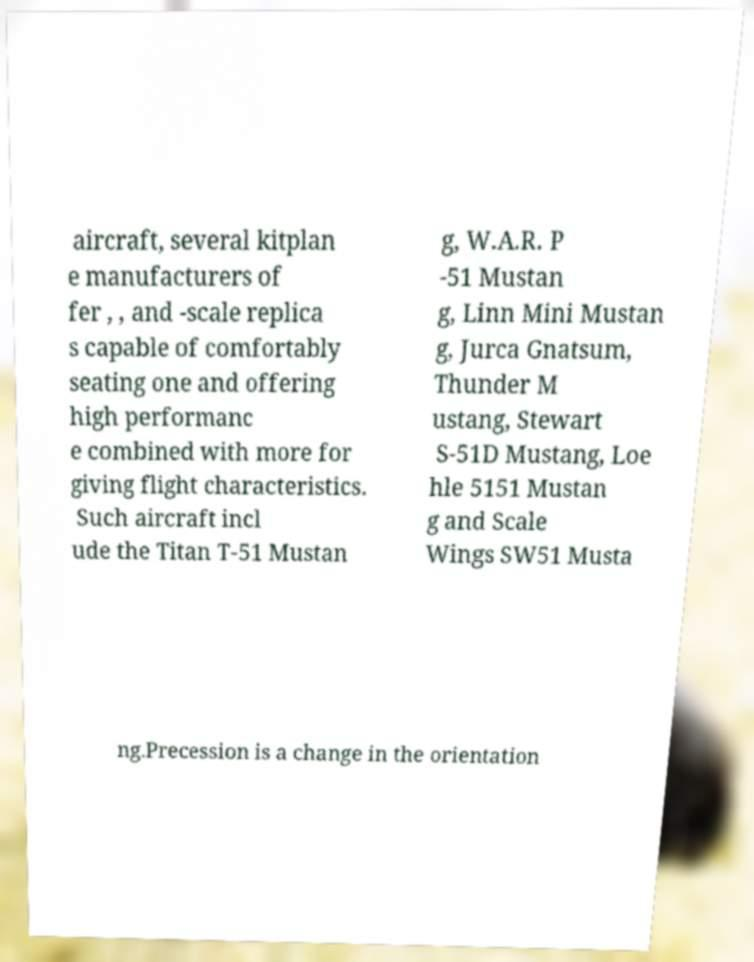Could you assist in decoding the text presented in this image and type it out clearly? aircraft, several kitplan e manufacturers of fer , , and -scale replica s capable of comfortably seating one and offering high performanc e combined with more for giving flight characteristics. Such aircraft incl ude the Titan T-51 Mustan g, W.A.R. P -51 Mustan g, Linn Mini Mustan g, Jurca Gnatsum, Thunder M ustang, Stewart S-51D Mustang, Loe hle 5151 Mustan g and Scale Wings SW51 Musta ng.Precession is a change in the orientation 